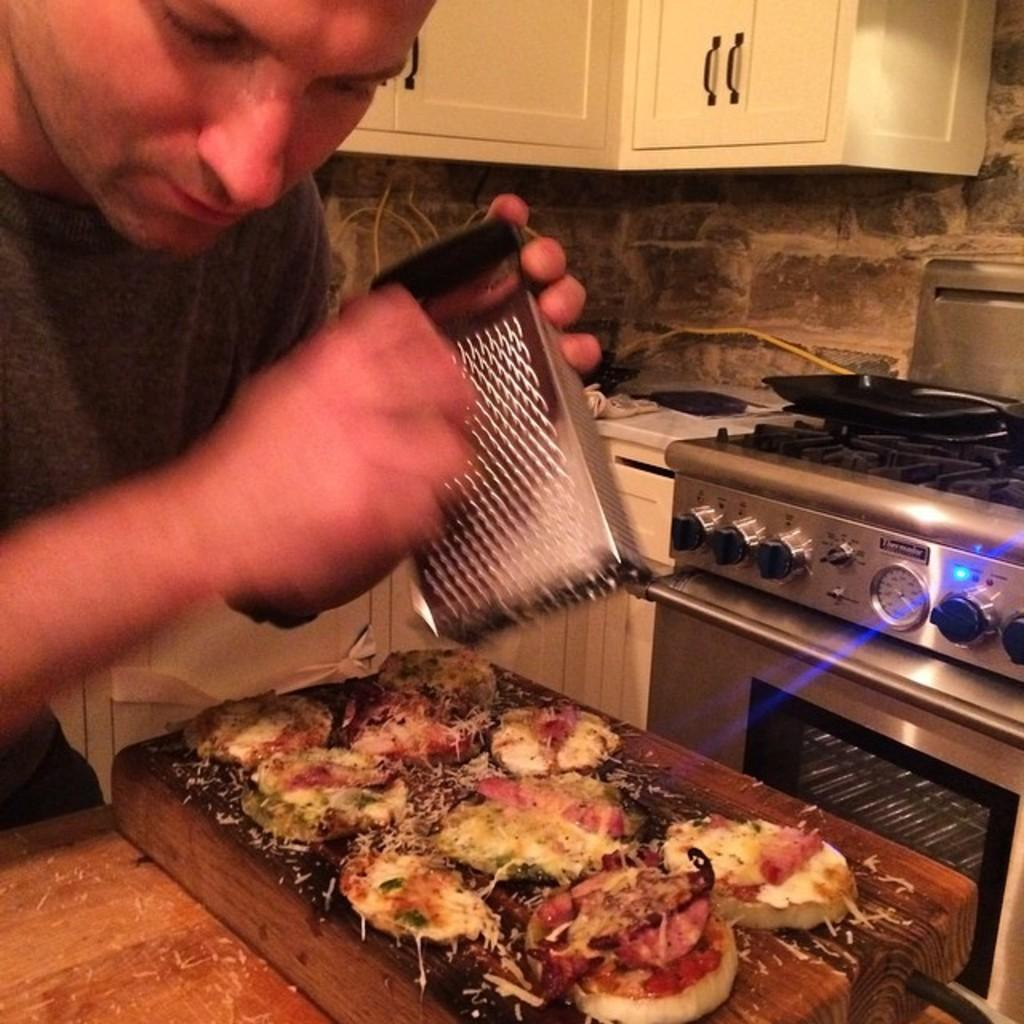What is the main subject of the image? There is a person in the image. What is the person doing in the image? The person is standing and garnishing something on food. Where is the food located in relation to the person? The food is in front of the person. What can be seen near the person in the image? There is a stove beside the person. How many baskets are visible in the image? There are no baskets present in the image. What is the mass of the food being garnished by the person? The mass of the food cannot be determined from the image alone. 